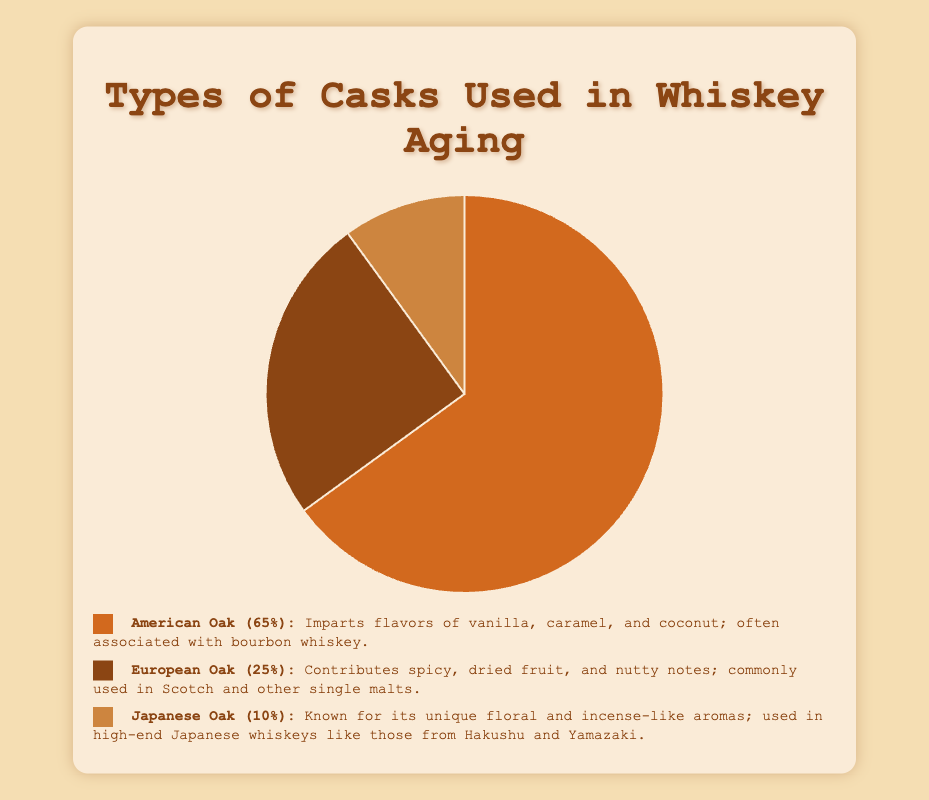What proportion of casks are made from Japanese Oak? The pie chart shows that Japanese Oak casks are used in 10% of the aging process.
Answer: 10% What type of cask is used the most for aging whiskey? The pie chart indicates that American Oak casks are used the most, accounting for 65% of the total.
Answer: American Oak Which type of cask imparts vanilla and caramel flavors? The legend specifies that American Oak casks impart flavors of vanilla, caramel, and coconut.
Answer: American Oak How much more are American Oak casks used compared to European Oak casks? American Oak casks account for 65% and European Oak for 25%. The difference is 65% - 25% = 40%.
Answer: 40% What percentage of casks used are either European or Japanese Oak? The proportions for European Oak and Japanese Oak are 25% and 10%, respectively. Summing these gives 25% + 10% = 35%.
Answer: 35% Which type of cask is associated with a majority of Scotch and other single malts? The legend states that European Oak is commonly used in Scotch and other single malts.
Answer: European Oak Are European Oak casks used more or less than Japanese Oak casks? The pie chart shows that European Oak is used for 25% of the casks, while Japanese Oak is used for 10%. Thus, European Oak is used more.
Answer: More Describe the aroma characteristics of Japanese Oak casks. According to the legend, Japanese Oak casks are known for their unique floral and incense-like aromas.
Answer: Floral and incense-like aromas 